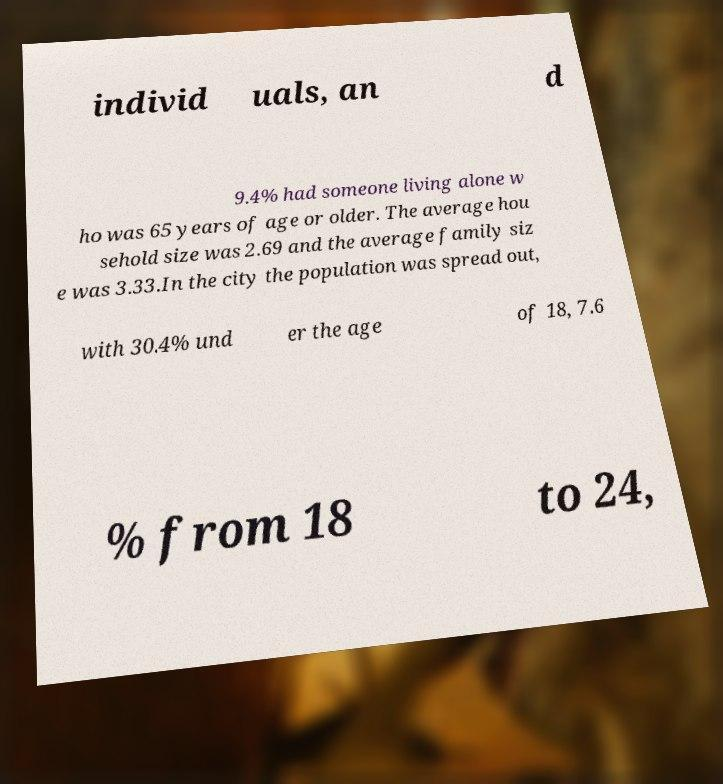There's text embedded in this image that I need extracted. Can you transcribe it verbatim? individ uals, an d 9.4% had someone living alone w ho was 65 years of age or older. The average hou sehold size was 2.69 and the average family siz e was 3.33.In the city the population was spread out, with 30.4% und er the age of 18, 7.6 % from 18 to 24, 